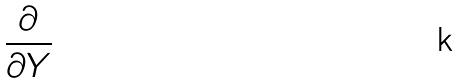<formula> <loc_0><loc_0><loc_500><loc_500>\frac { \partial } { \partial Y }</formula> 